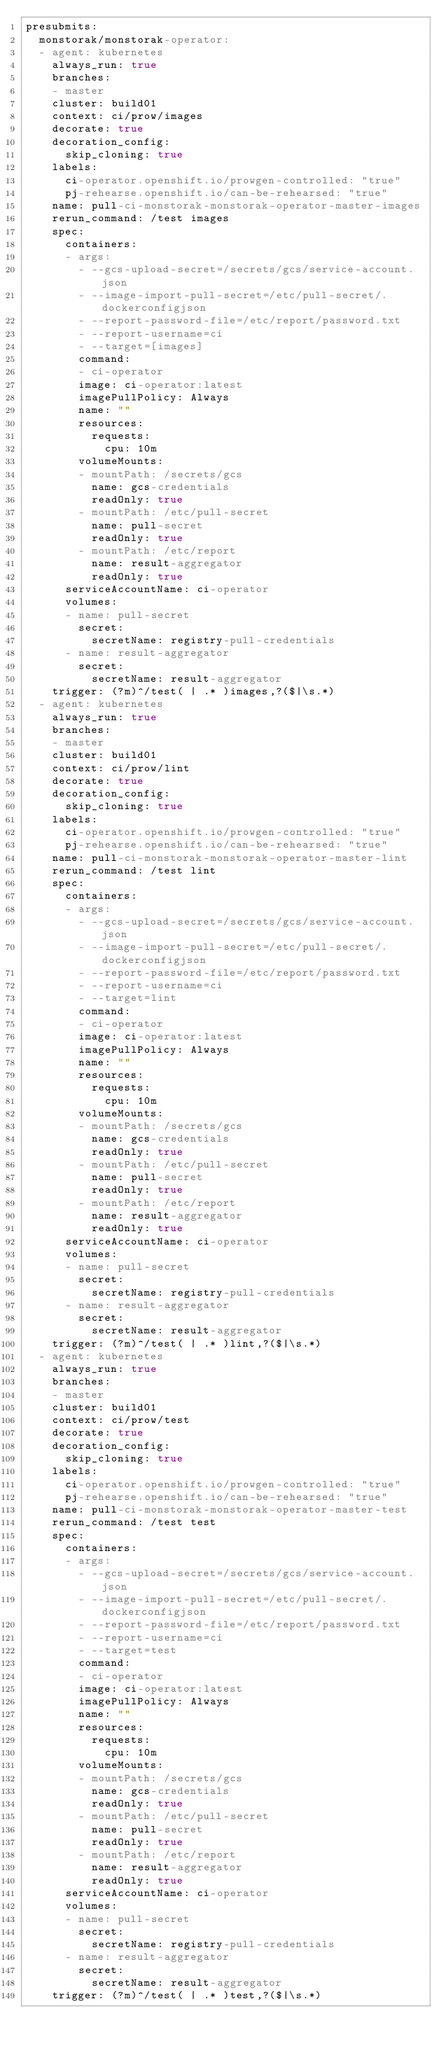<code> <loc_0><loc_0><loc_500><loc_500><_YAML_>presubmits:
  monstorak/monstorak-operator:
  - agent: kubernetes
    always_run: true
    branches:
    - master
    cluster: build01
    context: ci/prow/images
    decorate: true
    decoration_config:
      skip_cloning: true
    labels:
      ci-operator.openshift.io/prowgen-controlled: "true"
      pj-rehearse.openshift.io/can-be-rehearsed: "true"
    name: pull-ci-monstorak-monstorak-operator-master-images
    rerun_command: /test images
    spec:
      containers:
      - args:
        - --gcs-upload-secret=/secrets/gcs/service-account.json
        - --image-import-pull-secret=/etc/pull-secret/.dockerconfigjson
        - --report-password-file=/etc/report/password.txt
        - --report-username=ci
        - --target=[images]
        command:
        - ci-operator
        image: ci-operator:latest
        imagePullPolicy: Always
        name: ""
        resources:
          requests:
            cpu: 10m
        volumeMounts:
        - mountPath: /secrets/gcs
          name: gcs-credentials
          readOnly: true
        - mountPath: /etc/pull-secret
          name: pull-secret
          readOnly: true
        - mountPath: /etc/report
          name: result-aggregator
          readOnly: true
      serviceAccountName: ci-operator
      volumes:
      - name: pull-secret
        secret:
          secretName: registry-pull-credentials
      - name: result-aggregator
        secret:
          secretName: result-aggregator
    trigger: (?m)^/test( | .* )images,?($|\s.*)
  - agent: kubernetes
    always_run: true
    branches:
    - master
    cluster: build01
    context: ci/prow/lint
    decorate: true
    decoration_config:
      skip_cloning: true
    labels:
      ci-operator.openshift.io/prowgen-controlled: "true"
      pj-rehearse.openshift.io/can-be-rehearsed: "true"
    name: pull-ci-monstorak-monstorak-operator-master-lint
    rerun_command: /test lint
    spec:
      containers:
      - args:
        - --gcs-upload-secret=/secrets/gcs/service-account.json
        - --image-import-pull-secret=/etc/pull-secret/.dockerconfigjson
        - --report-password-file=/etc/report/password.txt
        - --report-username=ci
        - --target=lint
        command:
        - ci-operator
        image: ci-operator:latest
        imagePullPolicy: Always
        name: ""
        resources:
          requests:
            cpu: 10m
        volumeMounts:
        - mountPath: /secrets/gcs
          name: gcs-credentials
          readOnly: true
        - mountPath: /etc/pull-secret
          name: pull-secret
          readOnly: true
        - mountPath: /etc/report
          name: result-aggregator
          readOnly: true
      serviceAccountName: ci-operator
      volumes:
      - name: pull-secret
        secret:
          secretName: registry-pull-credentials
      - name: result-aggregator
        secret:
          secretName: result-aggregator
    trigger: (?m)^/test( | .* )lint,?($|\s.*)
  - agent: kubernetes
    always_run: true
    branches:
    - master
    cluster: build01
    context: ci/prow/test
    decorate: true
    decoration_config:
      skip_cloning: true
    labels:
      ci-operator.openshift.io/prowgen-controlled: "true"
      pj-rehearse.openshift.io/can-be-rehearsed: "true"
    name: pull-ci-monstorak-monstorak-operator-master-test
    rerun_command: /test test
    spec:
      containers:
      - args:
        - --gcs-upload-secret=/secrets/gcs/service-account.json
        - --image-import-pull-secret=/etc/pull-secret/.dockerconfigjson
        - --report-password-file=/etc/report/password.txt
        - --report-username=ci
        - --target=test
        command:
        - ci-operator
        image: ci-operator:latest
        imagePullPolicy: Always
        name: ""
        resources:
          requests:
            cpu: 10m
        volumeMounts:
        - mountPath: /secrets/gcs
          name: gcs-credentials
          readOnly: true
        - mountPath: /etc/pull-secret
          name: pull-secret
          readOnly: true
        - mountPath: /etc/report
          name: result-aggregator
          readOnly: true
      serviceAccountName: ci-operator
      volumes:
      - name: pull-secret
        secret:
          secretName: registry-pull-credentials
      - name: result-aggregator
        secret:
          secretName: result-aggregator
    trigger: (?m)^/test( | .* )test,?($|\s.*)
</code> 